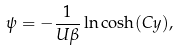<formula> <loc_0><loc_0><loc_500><loc_500>\psi = - \frac { 1 } { U \beta } \ln \cosh ( C y ) ,</formula> 